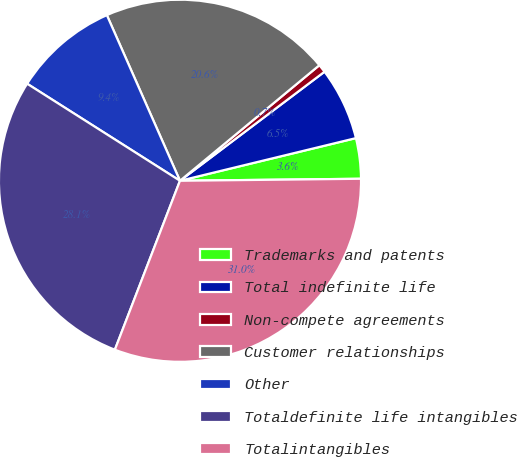Convert chart. <chart><loc_0><loc_0><loc_500><loc_500><pie_chart><fcel>Trademarks and patents<fcel>Total indefinite life<fcel>Non-compete agreements<fcel>Customer relationships<fcel>Other<fcel>Totaldefinite life intangibles<fcel>Totalintangibles<nl><fcel>3.61%<fcel>6.5%<fcel>0.73%<fcel>20.6%<fcel>9.38%<fcel>28.15%<fcel>31.03%<nl></chart> 